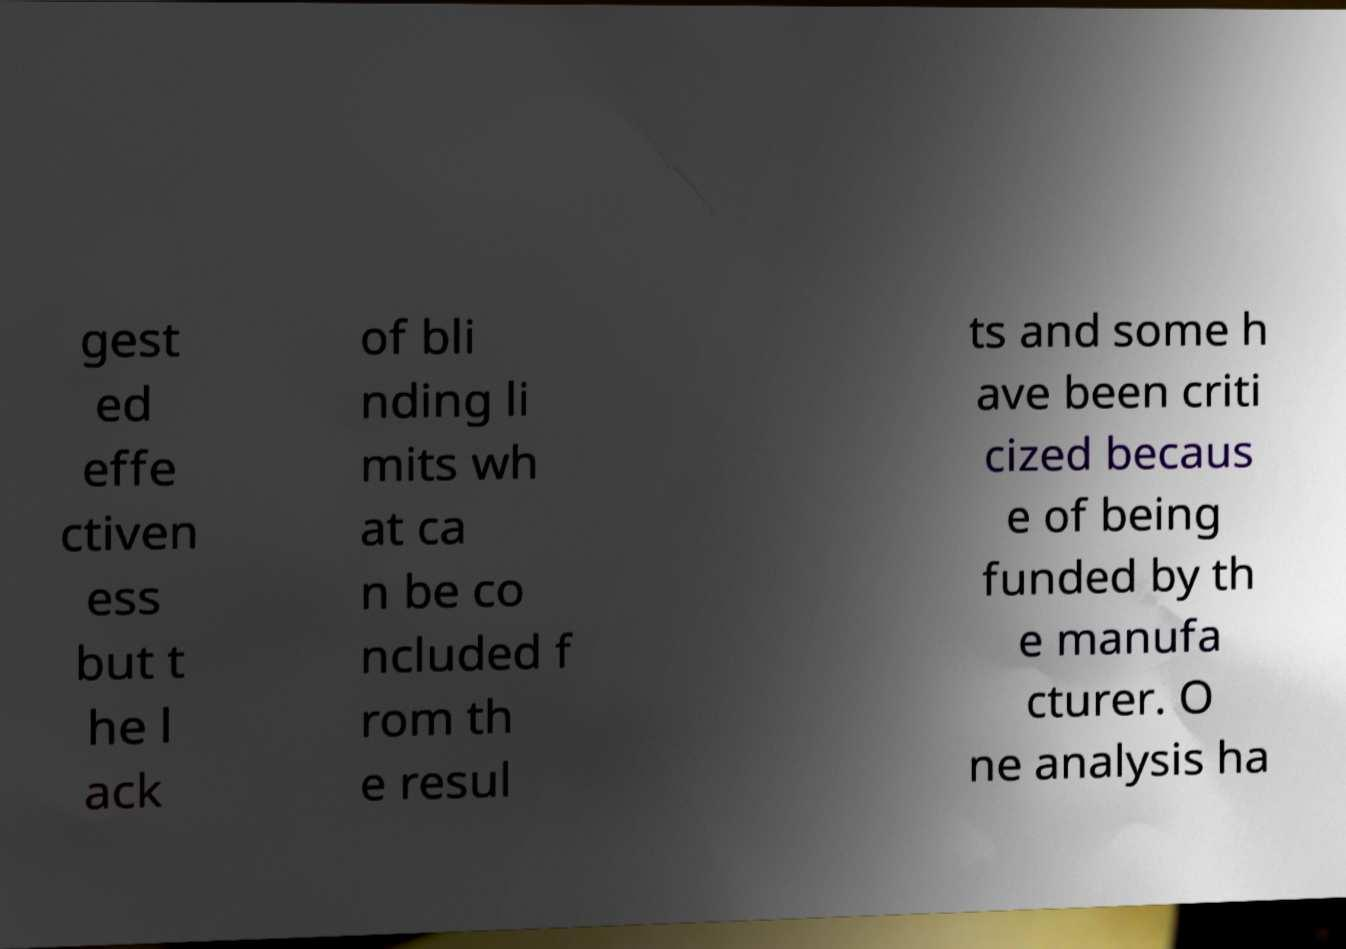Could you assist in decoding the text presented in this image and type it out clearly? gest ed effe ctiven ess but t he l ack of bli nding li mits wh at ca n be co ncluded f rom th e resul ts and some h ave been criti cized becaus e of being funded by th e manufa cturer. O ne analysis ha 